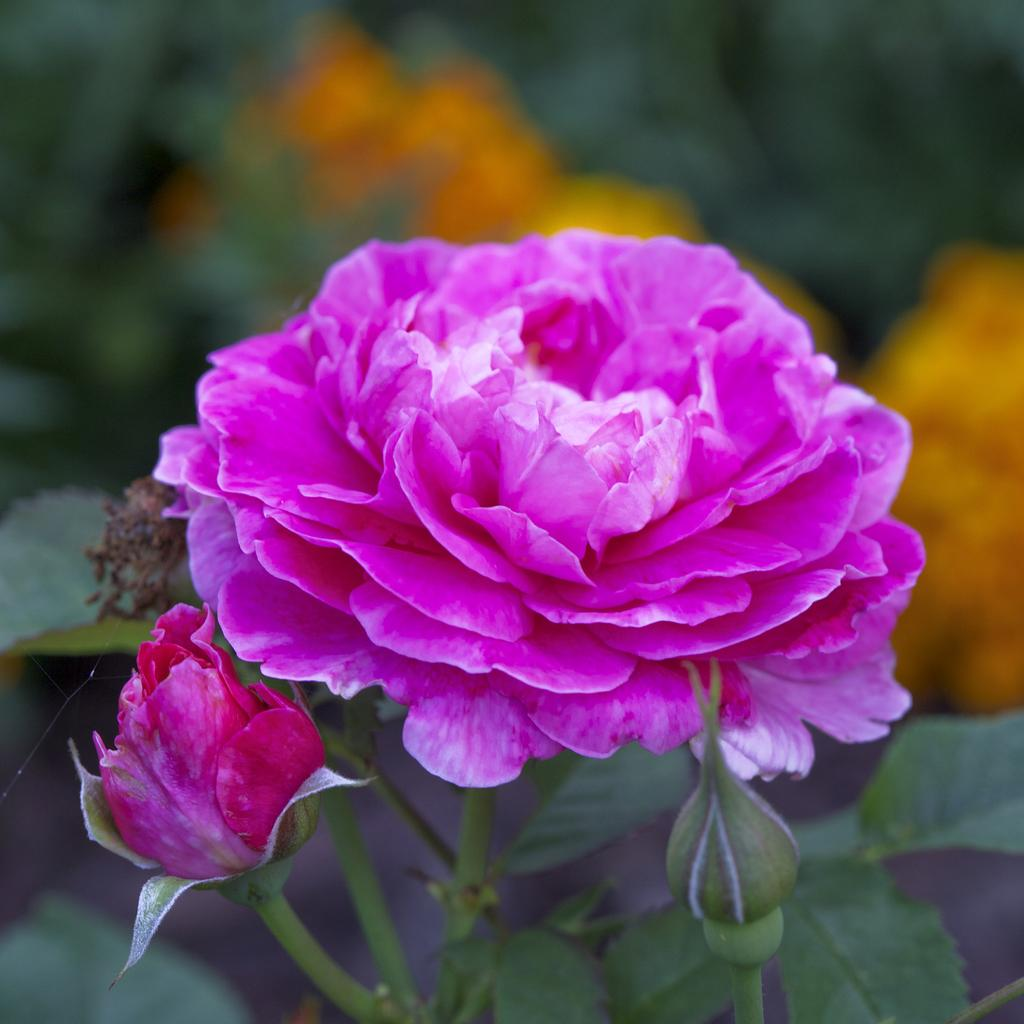What type of flower is in the image? There is a rose in the image. Can you describe the stage of growth of the plant in the image? There is a bud on the stem of a plant in the image. What type of fowl can be seen in the image? There is no fowl present in the image; it only features a rose and a plant with a bud. 